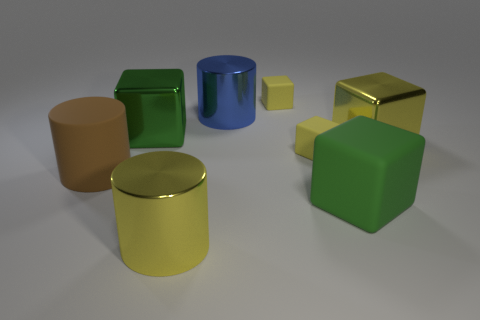Subtract all yellow shiny blocks. How many blocks are left? 4 Subtract all green cubes. How many cubes are left? 3 Add 1 yellow things. How many objects exist? 9 Subtract 0 green balls. How many objects are left? 8 Subtract all blocks. How many objects are left? 3 Subtract 1 cylinders. How many cylinders are left? 2 Subtract all brown cubes. Subtract all blue balls. How many cubes are left? 5 Subtract all brown cylinders. How many yellow blocks are left? 3 Subtract all tiny gray metallic things. Subtract all large matte things. How many objects are left? 6 Add 8 large blue metal cylinders. How many large blue metal cylinders are left? 9 